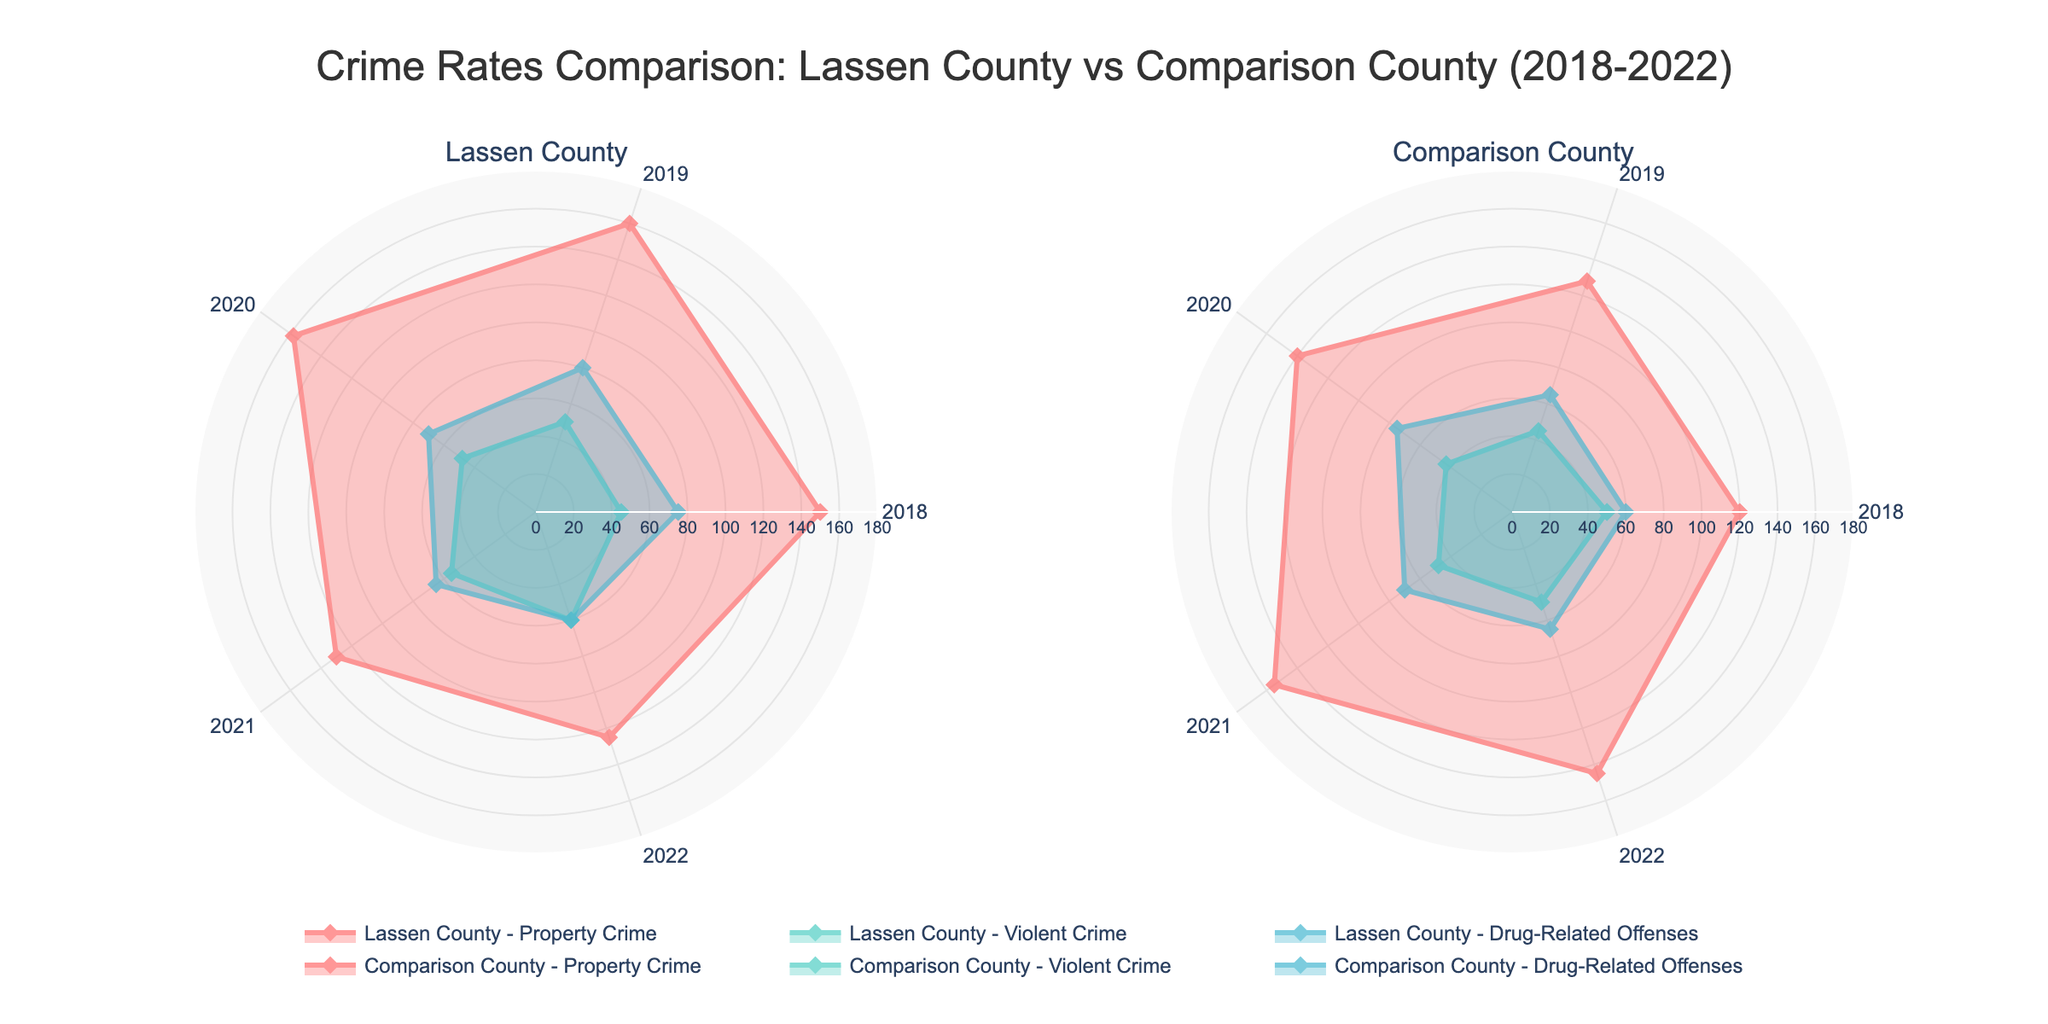What are the categories compared in the figure? The categories compared in the figure are listed in the radar chart titles and legend. For both Lassen County and the Comparison County, the categories are Property Crime, Violent Crime, and Drug-Related Offenses.
Answer: Property Crime, Violent Crime, Drug-Related Offenses Which county had a higher rate of Drug-Related Offenses in 2022? To determine which county had a higher rate of Drug-Related Offenses in 2022, compare the values on the radar chart. The figure shows Lassen County at 60 and the Comparison County at 65.
Answer: Comparison County In which year did Lassen County see the highest rate of Violent Crime? Look at the line for Lassen County's Violent Crime on the radar chart and identify the highest point. The highest value is 60, which occurs in 2022.
Answer: 2022 How do the 2021 Property Crime rates compare between Lassen County and the Comparison County? To compare the Property Crime rates in 2021, observe the respective points for each county on the radar chart. Lassen County has a value of 130, while the Comparison County has a value of 155.
Answer: Lassen County: 130, Comparison County: 155 What was the general trend of Property Crime in Lassen County from 2018 to 2022? Examine the changes in values for Property Crime in Lassen County over the years on the radar chart. The trend shows a decline from 150 in 2018 to 125 in 2022.
Answer: Declining Which category had the most similar rates between Lassen County and the Comparison County in 2020? Compare the 2020 values for each category between Lassen County and the Comparison County. Property Crime rates are 158 for Lassen County and 140 for the Comparison County, Violent Crime rates are 48 for Lassen County and 43 for the Comparison County, and Drug-Related Offenses rates are 70 for Lassen County and 75 for the Comparison County. Violent Crime has the closest values (48 vs 43).
Answer: Violent Crime By how much did the rate of Violent Crime increase in Lassen County from 2018 to 2022? Look at the Violent Crime rates for Lassen County in 2018 and 2022 on the radar chart. The values are 45 in 2018 and 60 in 2022. The increase is calculated as 60 - 45.
Answer: 15 Which county shows a consistent decrease in Drug-Related Offenses from 2018 to 2022? Analyze the Drug-Related Offenses trend for both counties on the radar chart. Lassen County's values decrease from 75 in 2018 to 60 in 2022, and the Comparison County's values show an initial increase and then a decrease. Lassen County shows a consistent decrease.
Answer: Lassen County What is the sum of all 2022 crime rates for Lassen County? To find the total 2022 crime rates for Lassen County, add the values for Property Crime (125), Violent Crime (60), and Drug-Related Offenses (60) shown on the radar chart. The sum is 125 + 60 + 60.
Answer: 245 